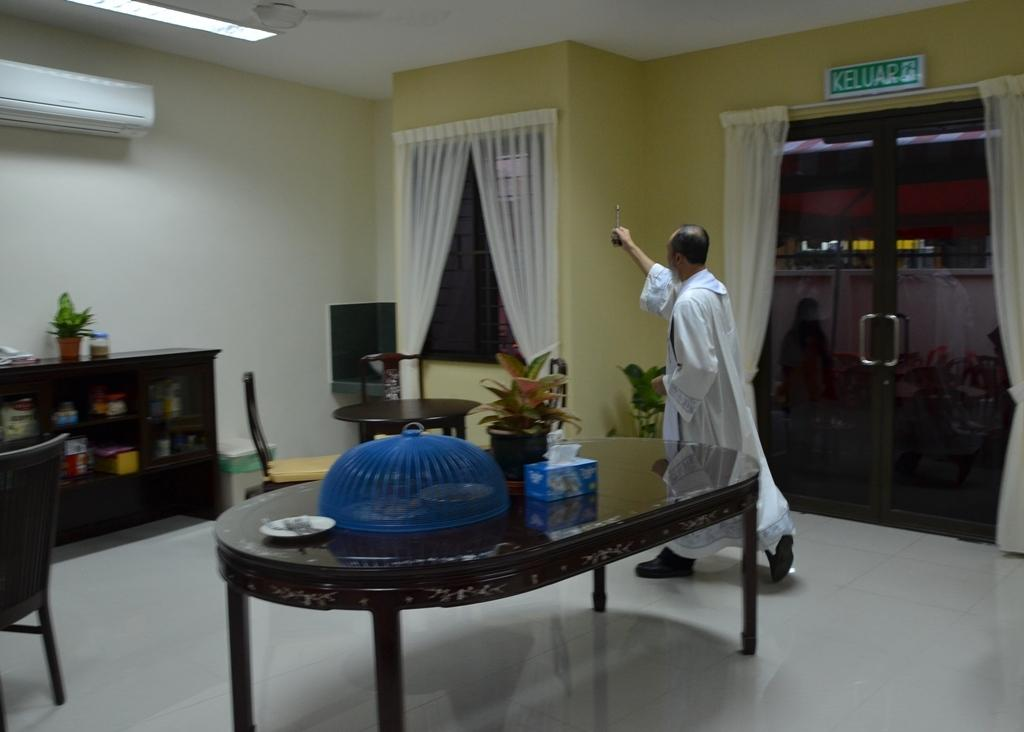What is the man in the image doing? The man is walking in the image. On which side of the image is the man walking? The man is walking on the left side. What can be seen in the image besides the man walking? There is a flower pot, a box on a table, a curtain, a wall, and a cupboard in the background. What subject is the man teaching in the image? There is no indication in the image that the man is teaching a subject. 